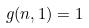<formula> <loc_0><loc_0><loc_500><loc_500>g ( n , 1 ) = 1</formula> 